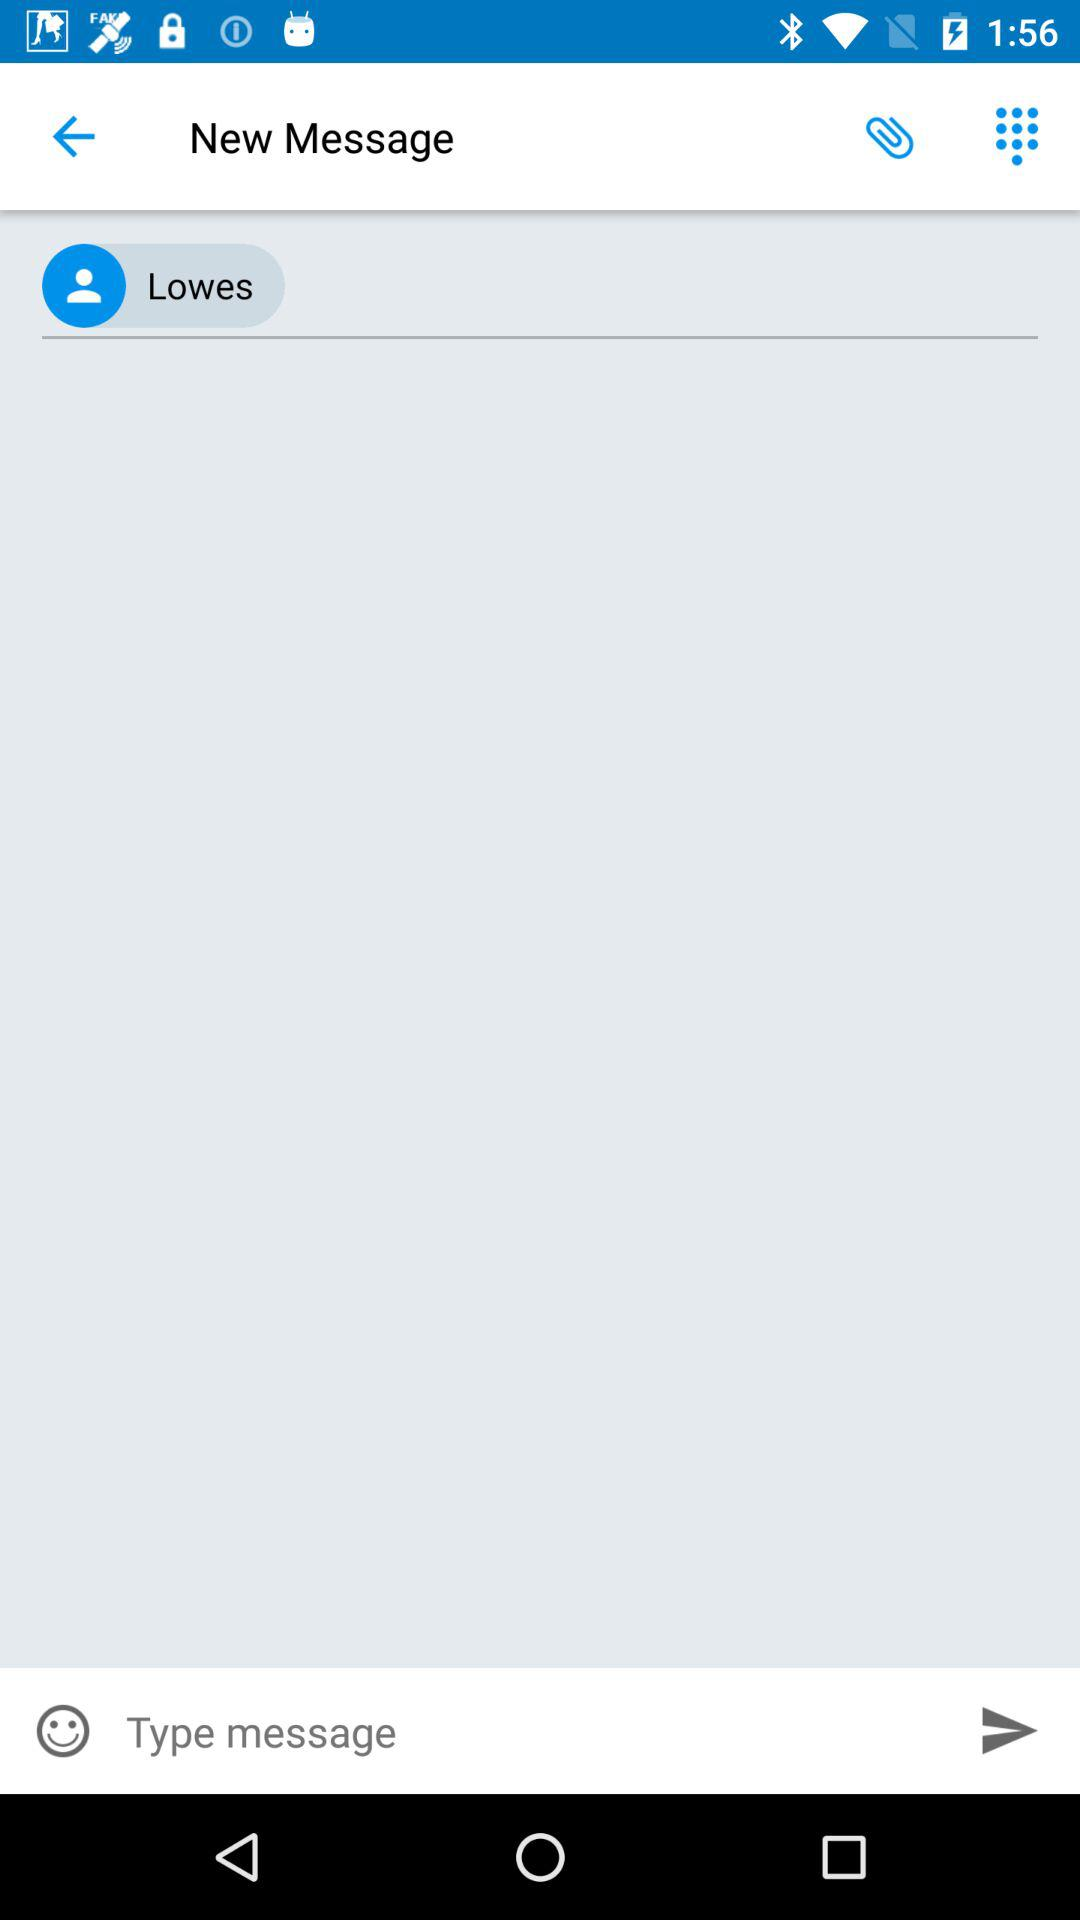What is the person name? The person name is Lowes. 